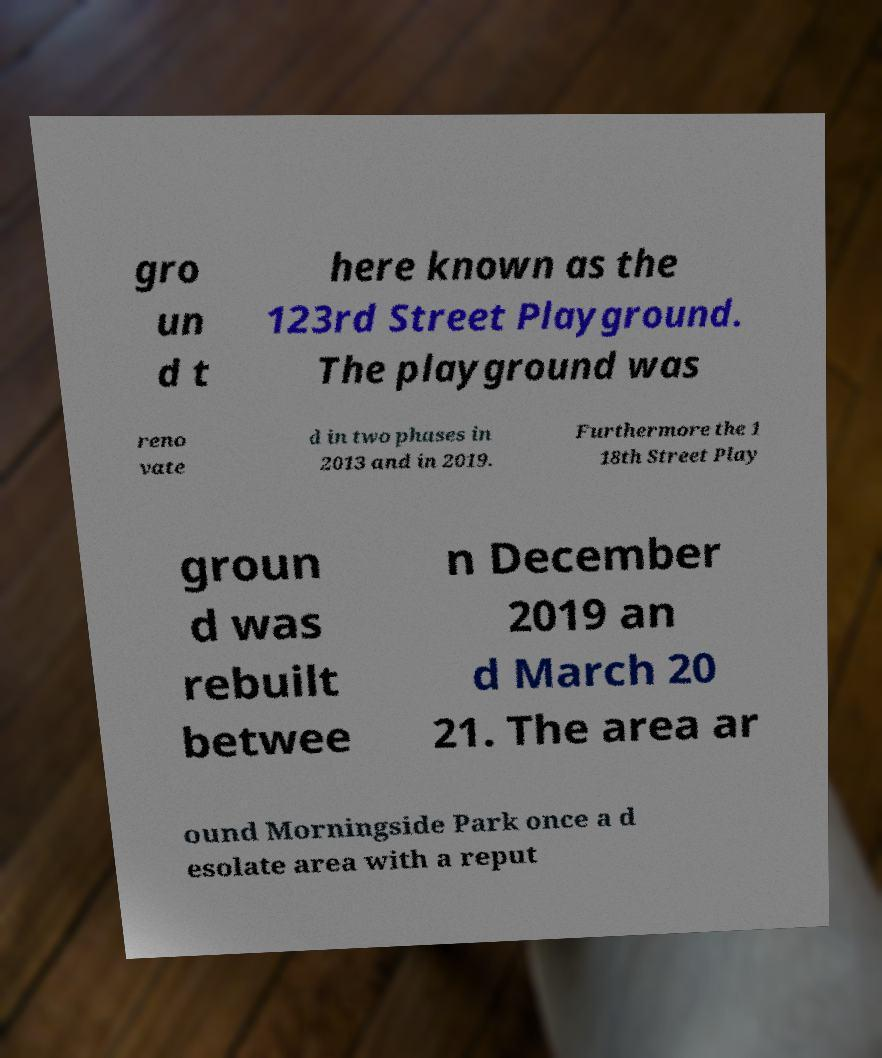Can you read and provide the text displayed in the image?This photo seems to have some interesting text. Can you extract and type it out for me? gro un d t here known as the 123rd Street Playground. The playground was reno vate d in two phases in 2013 and in 2019. Furthermore the 1 18th Street Play groun d was rebuilt betwee n December 2019 an d March 20 21. The area ar ound Morningside Park once a d esolate area with a reput 